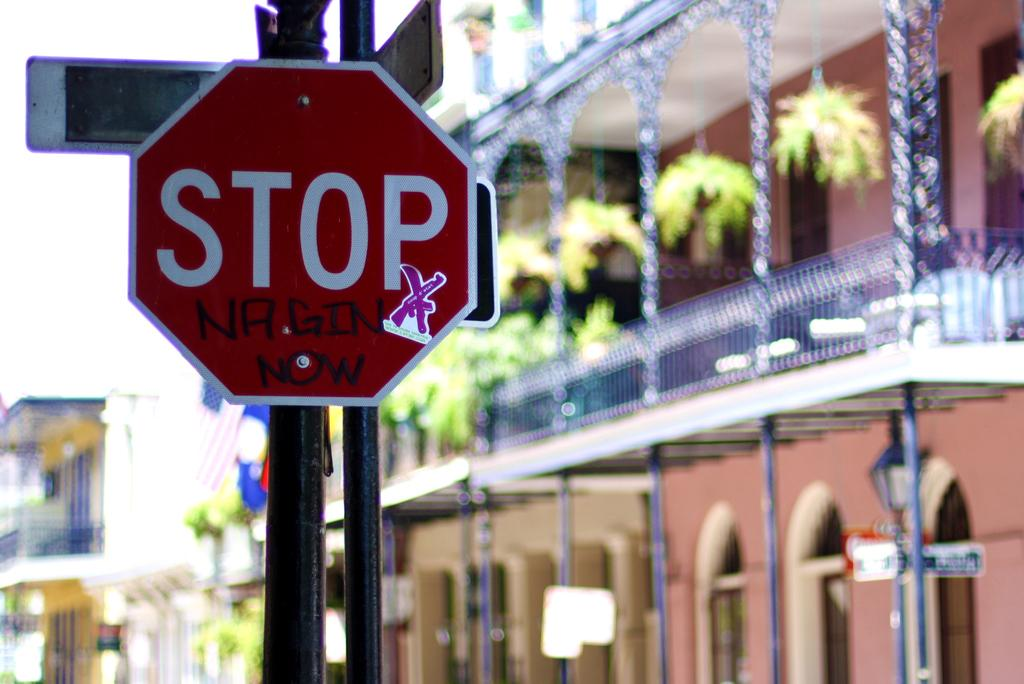<image>
Share a concise interpretation of the image provided. A stop sign with the the words, Nagin Now written in black. 